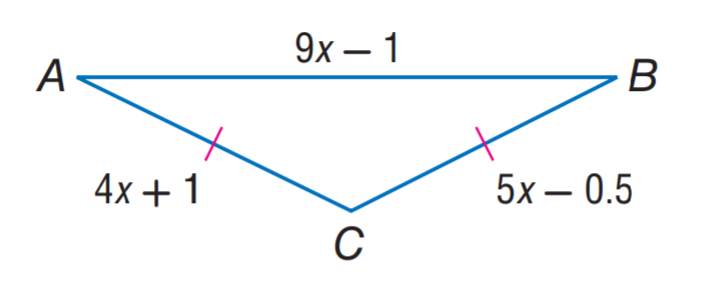Answer the mathemtical geometry problem and directly provide the correct option letter.
Question: Find the length of C B in the isosceles triangle A B C.
Choices: A: 1.5 B: 7 C: 11 D: 12.5 B 